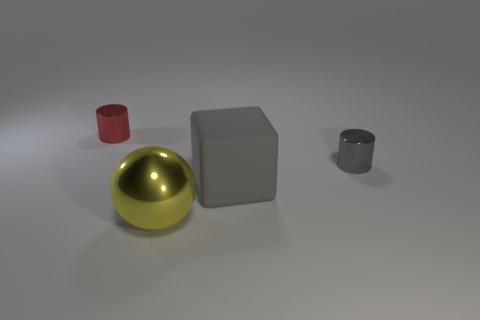Are there any other things that are the same material as the large gray block?
Your response must be concise. No. The other metallic thing that is the same shape as the red object is what color?
Provide a succinct answer. Gray. What number of objects are either metal things or big cubes that are to the right of the big yellow metallic ball?
Ensure brevity in your answer.  4. What is the material of the tiny red thing?
Provide a short and direct response. Metal. Are there any other things that have the same color as the matte cube?
Offer a terse response. Yes. Is the yellow thing the same shape as the red metal thing?
Provide a succinct answer. No. What size is the gray object to the left of the tiny metallic cylinder in front of the small thing behind the tiny gray metal cylinder?
Your answer should be very brief. Large. What number of other objects are there of the same material as the large block?
Offer a very short reply. 0. What is the color of the tiny metal cylinder that is on the right side of the tiny red metal object?
Provide a succinct answer. Gray. What material is the small cylinder on the right side of the metallic cylinder that is behind the tiny shiny cylinder that is in front of the small red metallic thing made of?
Offer a terse response. Metal. 